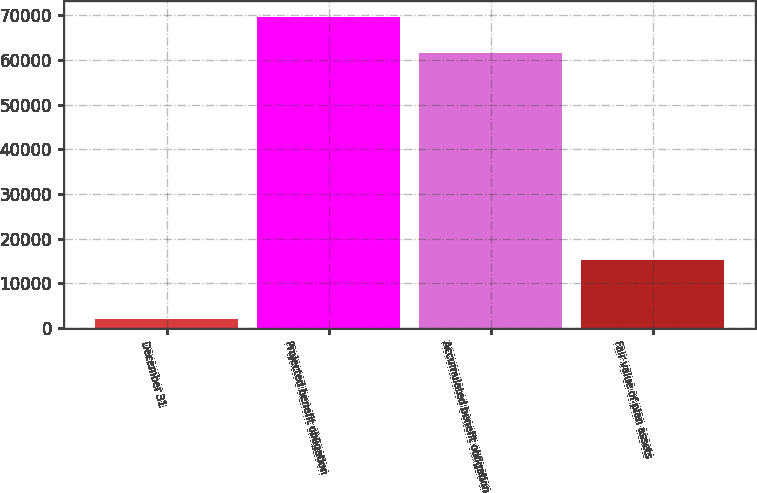Convert chart to OTSL. <chart><loc_0><loc_0><loc_500><loc_500><bar_chart><fcel>December 31<fcel>Projected benefit obligation<fcel>Accumulated benefit obligation<fcel>Fair value of plan assets<nl><fcel>2006<fcel>69633<fcel>61542<fcel>15275<nl></chart> 